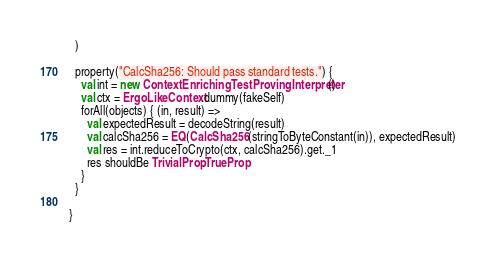<code> <loc_0><loc_0><loc_500><loc_500><_Scala_>  )

  property("CalcSha256: Should pass standard tests.") {
    val int = new ContextEnrichingTestProvingInterpreter()
    val ctx = ErgoLikeContext.dummy(fakeSelf)
    forAll(objects) { (in, result) =>
      val expectedResult = decodeString(result)
      val calcSha256 = EQ(CalcSha256(stringToByteConstant(in)), expectedResult)
      val res = int.reduceToCrypto(ctx, calcSha256).get._1
      res shouldBe TrivialProp.TrueProp
    }
  }

}</code> 